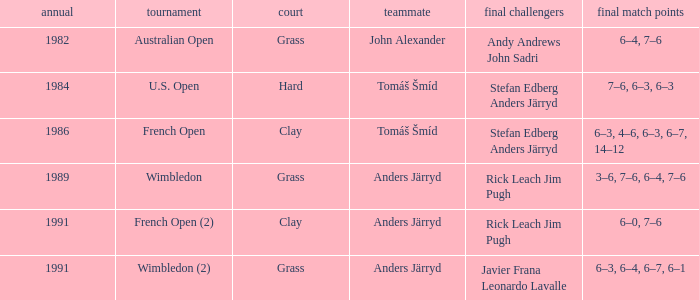What was the final score in 1986? 6–3, 4–6, 6–3, 6–7, 14–12. 